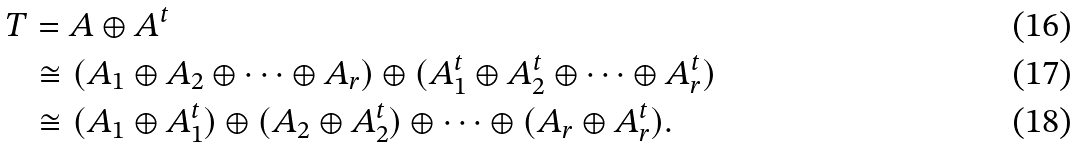<formula> <loc_0><loc_0><loc_500><loc_500>T & = A \oplus A ^ { t } \\ & \cong ( A _ { 1 } \oplus A _ { 2 } \oplus \cdots \oplus A _ { r } ) \oplus ( A _ { 1 } ^ { t } \oplus A _ { 2 } ^ { t } \oplus \cdots \oplus A _ { r } ^ { t } ) \\ & \cong ( A _ { 1 } \oplus A _ { 1 } ^ { t } ) \oplus ( A _ { 2 } \oplus A _ { 2 } ^ { t } ) \oplus \cdots \oplus ( A _ { r } \oplus A _ { r } ^ { t } ) .</formula> 